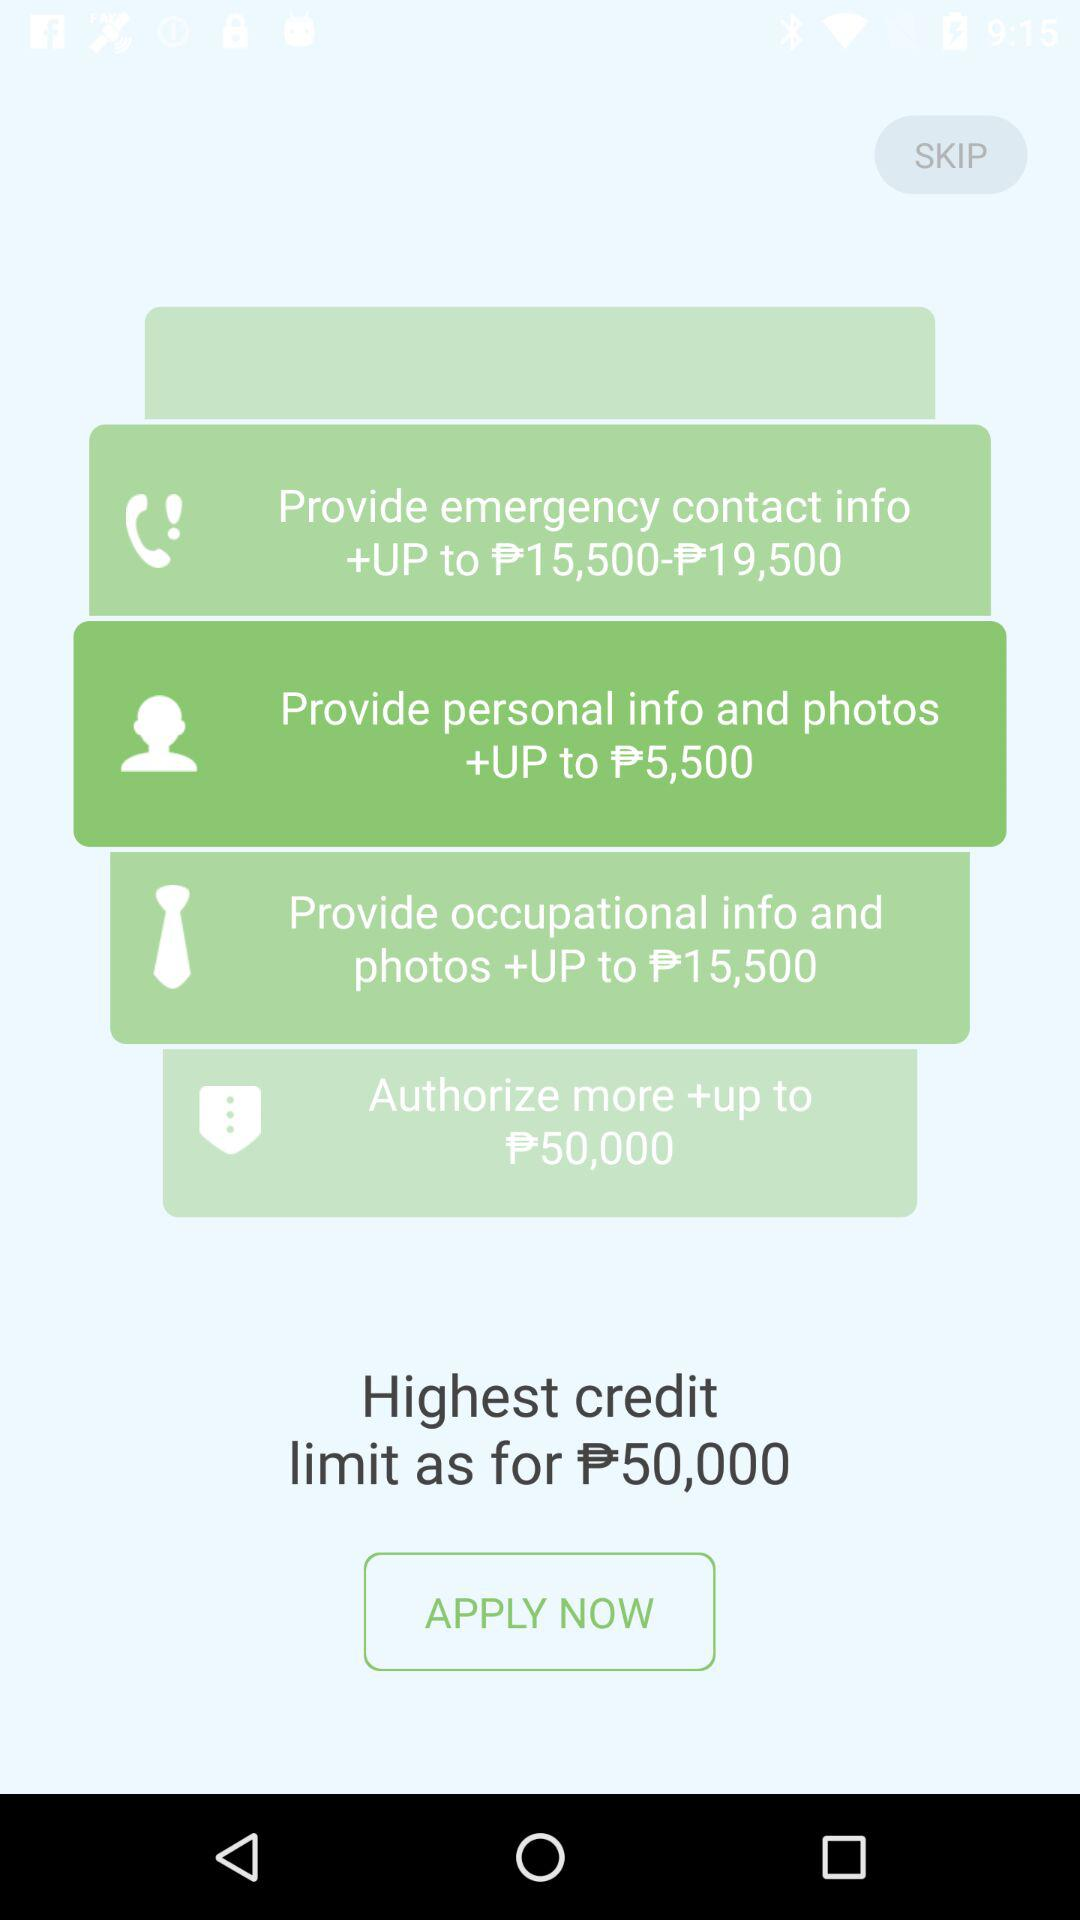What is the highest credit limit? The highest credit limit is ₱50,000. 